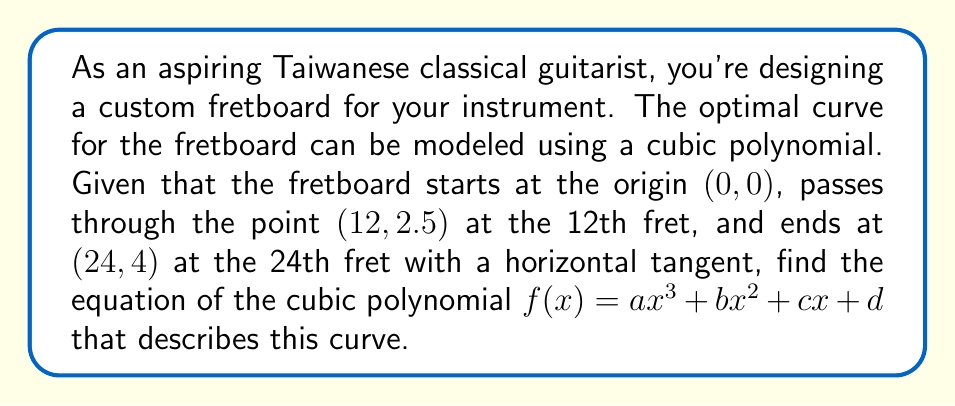Give your solution to this math problem. Let's approach this step-by-step:

1) We know that $f(x) = ax^3 + bx^2 + cx + d$

2) Given conditions:
   a) $f(0) = 0$ (starts at origin)
   b) $f(12) = 2.5$ (12th fret)
   c) $f(24) = 4$ (24th fret)
   d) $f'(24) = 0$ (horizontal tangent at the end)

3) From condition (a): $f(0) = d = 0$

4) Our polynomial is now: $f(x) = ax^3 + bx^2 + cx$

5) From condition (b): $f(12) = a(12^3) + b(12^2) + c(12) = 2.5$
   $1728a + 144b + 12c = 2.5$ ... (Equation 1)

6) From condition (c): $f(24) = a(24^3) + b(24^2) + c(24) = 4$
   $13824a + 576b + 24c = 4$ ... (Equation 2)

7) From condition (d): $f'(x) = 3ax^2 + 2bx + c$
   $f'(24) = 3a(24^2) + 2b(24) + c = 0$
   $1728a + 48b + c = 0$ ... (Equation 3)

8) Now we have a system of 3 equations with 3 unknowns. Solve this system:

   From Equation 3: $c = -1728a - 48b$

   Substitute this into Equations 1 and 2:

   $1728a + 144b + 12(-1728a - 48b) = 2.5$
   $1728a + 144b - 20736a - 576b = 2.5$
   $-19008a - 432b = 2.5$ ... (Equation 4)

   $13824a + 576b + 24(-1728a - 48b) = 4$
   $13824a + 576b - 41472a - 1152b = 4$
   $-27648a - 576b = 4$ ... (Equation 5)

9) From Equation 4: $b = -\frac{19008a + 2.5}{432}$

   Substitute this into Equation 5:

   $-27648a - 576(-\frac{19008a + 2.5}{432}) = 4$
   $-27648a + 25344a + 3.33333 = 4$
   $-2304a = 0.66667$
   $a = -0.00028935$

10) Substitute this value of $a$ back to find $b$ and $c$:

    $b = 0.0138889$
    $c = 0.1666667$

Therefore, the equation of the cubic polynomial is:
$f(x) = -0.00028935x^3 + 0.0138889x^2 + 0.1666667x$
Answer: $f(x) = -0.00028935x^3 + 0.0138889x^2 + 0.1666667x$ 